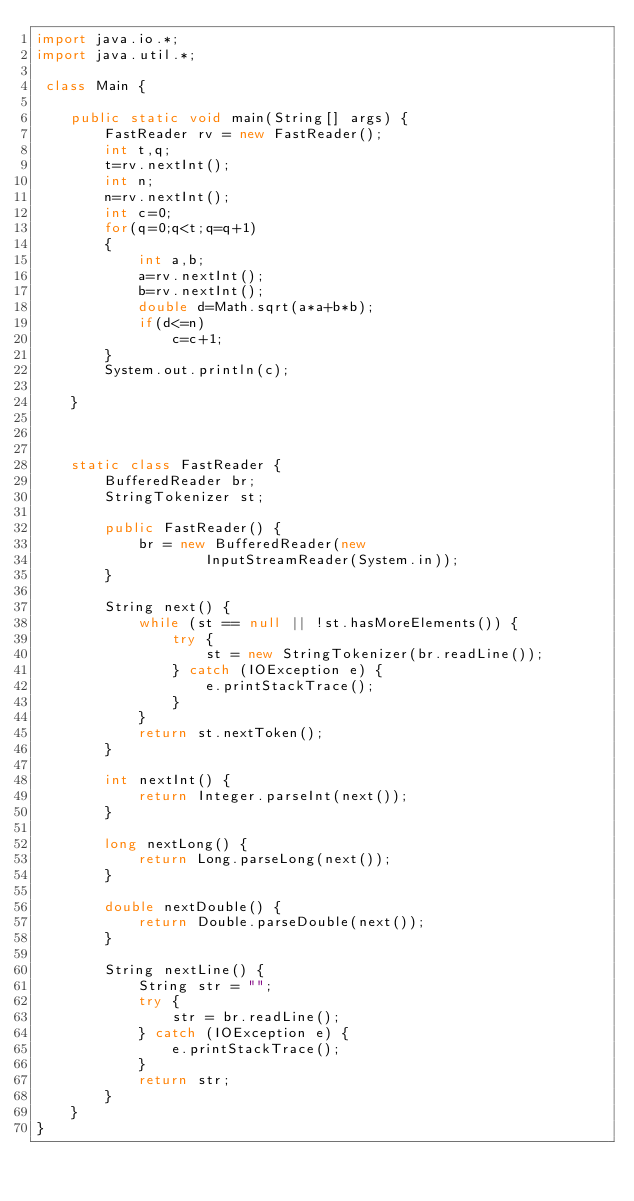Convert code to text. <code><loc_0><loc_0><loc_500><loc_500><_Java_>import java.io.*;
import java.util.*;

 class Main {

    public static void main(String[] args) {
        FastReader rv = new FastReader();
        int t,q;
        t=rv.nextInt();
        int n;
        n=rv.nextInt();
        int c=0;
        for(q=0;q<t;q=q+1)
        {
            int a,b;
            a=rv.nextInt();
            b=rv.nextInt();
            double d=Math.sqrt(a*a+b*b);
            if(d<=n)
                c=c+1;
        }
        System.out.println(c);

    }



    static class FastReader {
        BufferedReader br;
        StringTokenizer st;

        public FastReader() {
            br = new BufferedReader(new
                    InputStreamReader(System.in));
        }

        String next() {
            while (st == null || !st.hasMoreElements()) {
                try {
                    st = new StringTokenizer(br.readLine());
                } catch (IOException e) {
                    e.printStackTrace();
                }
            }
            return st.nextToken();
        }

        int nextInt() {
            return Integer.parseInt(next());
        }

        long nextLong() {
            return Long.parseLong(next());
        }

        double nextDouble() {
            return Double.parseDouble(next());
        }

        String nextLine() {
            String str = "";
            try {
                str = br.readLine();
            } catch (IOException e) {
                e.printStackTrace();
            }
            return str;
        }
    }
}</code> 